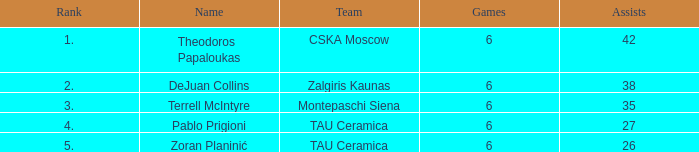Give me the full table as a dictionary. {'header': ['Rank', 'Name', 'Team', 'Games', 'Assists'], 'rows': [['1.', 'Theodoros Papaloukas', 'CSKA Moscow', '6', '42'], ['2.', 'DeJuan Collins', 'Zalgiris Kaunas', '6', '38'], ['3.', 'Terrell McIntyre', 'Montepaschi Siena', '6', '35'], ['4.', 'Pablo Prigioni', 'TAU Ceramica', '6', '27'], ['5.', 'Zoran Planinić', 'TAU Ceramica', '6', '26']]} What is the least number of assists among players ranked 2? 38.0. 